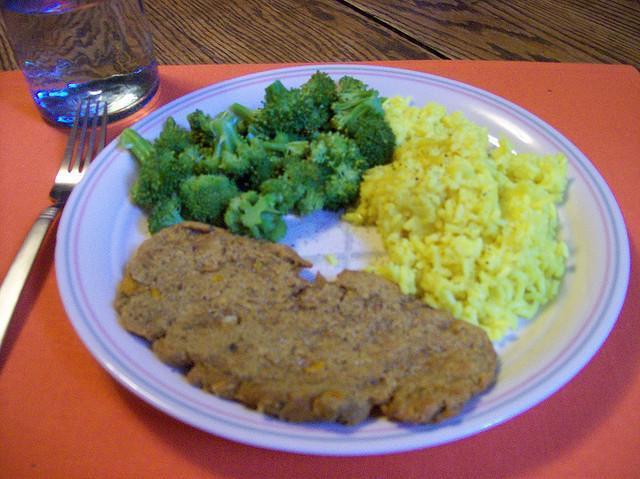How many different types of foods are here?
Give a very brief answer. 3. How many people are cutting cake in the image?
Give a very brief answer. 0. 